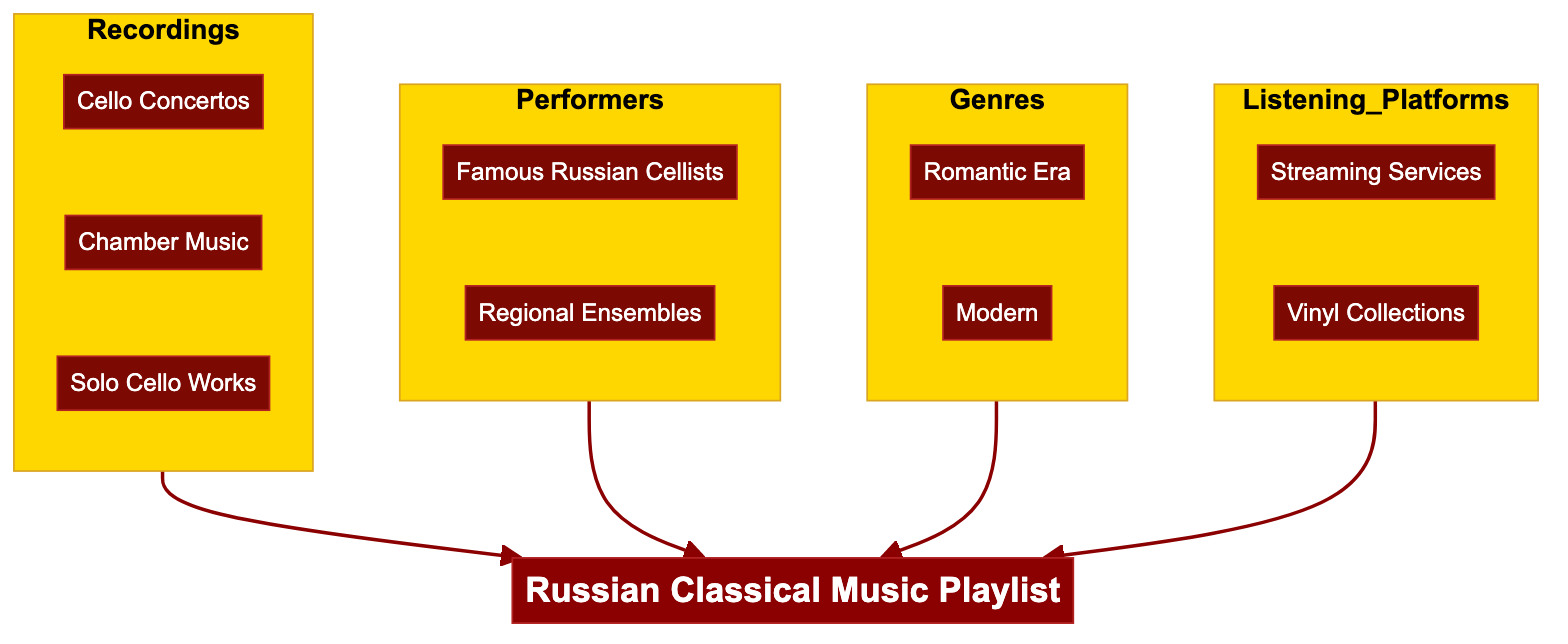What are the main categories in the diagram? The diagram has four main categories: Recordings, Performers, Genres, and Listening Platforms, indicated as separate subgraphs in the flowchart.
Answer: Recordings, Performers, Genres, Listening Platforms How many examples are listed under Cello Concertos? The Cello Concertos category has two examples: "Dmitri Shostakovich - Cello Concerto No. 1" and "Sergei Prokofiev - Sinfonia Concertante".
Answer: 2 Which genre includes "Anton Rubinstein - Cello Concerto"? The example "Anton Rubinstein - Cello Concerto" is found under the Romantic Era genre, as indicated in the Genres subgraph.
Answer: Romantic Era What type of performers are shown in the diagram? The diagram identifies two types of performers: Famous Russian Cellists and Regional Ensembles, grouped under the Performers category.
Answer: Famous Russian Cellists, Regional Ensembles Count the number of listening platform types. There are two types of listening platforms labeled in the diagram: Streaming Services and Vinyl Collections.
Answer: 2 Which recording type has "Shostakovich - Sonata for Cello and Piano"? The recording type "Shostakovich - Sonata for Cello and Piano" falls under the Modern category within the Genres subgraph of the diagram.
Answer: Modern What is the final output of the flowchart? The final output that combines all categories leads to the "Russian Classical Music Playlist", which is depicted as the main node at the end of the diagram flow.
Answer: Russian Classical Music Playlist How many examples are under the Chamber Music category? The Chamber Music category contains two examples: "Anton Arensky - Piano Trio No. 1" and "Dmitri Shostakovich - String Quartet No. 8." This indicates the diversity of this recording type.
Answer: 2 Which listening platform includes Spotify? The example "Spotify" is listed under the Streaming Services category, part of the Listening Platforms section of the flowchart.
Answer: Streaming Services 